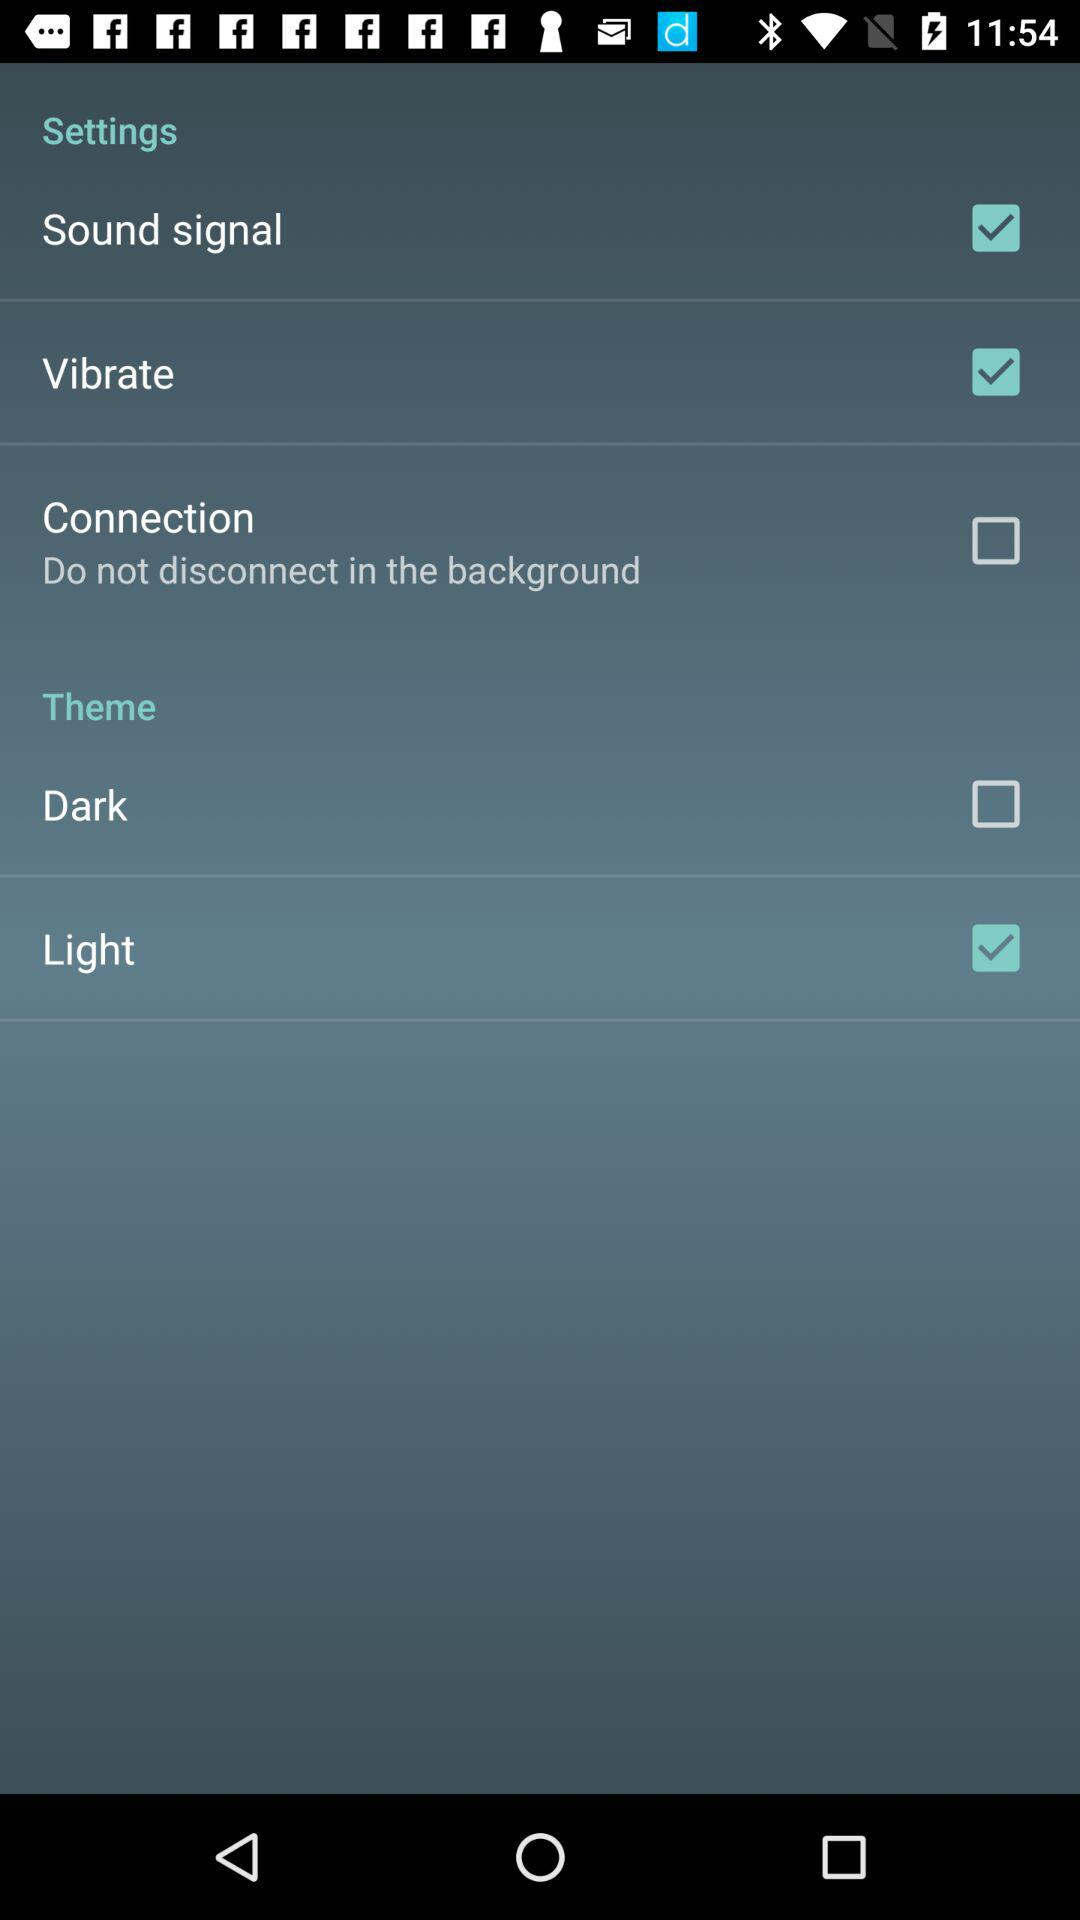What is the status of the "Sound signal" setting? The status is "on". 